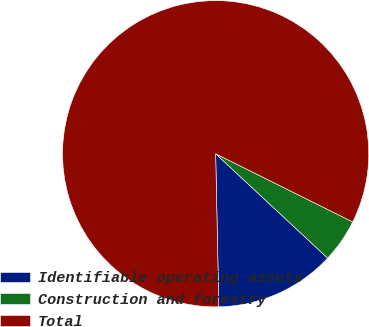Convert chart to OTSL. <chart><loc_0><loc_0><loc_500><loc_500><pie_chart><fcel>Identifiable operating assets<fcel>Construction and forestry<fcel>Total<nl><fcel>12.73%<fcel>4.59%<fcel>82.68%<nl></chart> 